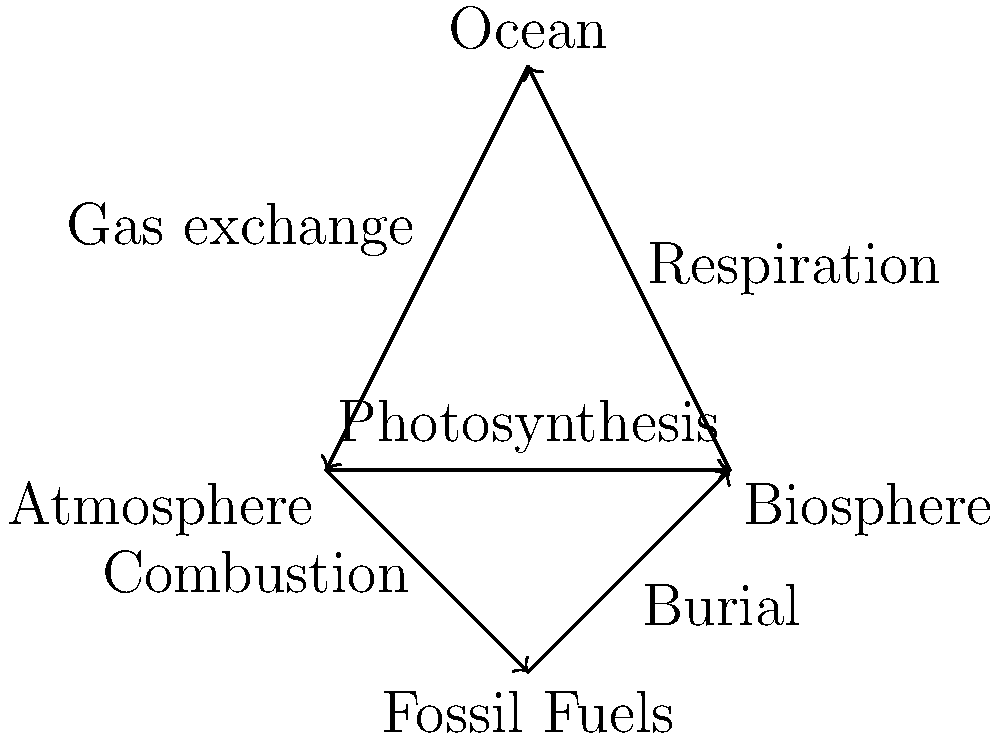In the carbon cycle diagram, which process counteracts the flow of carbon from the atmosphere to the biosphere through photosynthesis? To answer this question, let's analyze the carbon cycle diagram step-by-step:

1. First, we identify the flow of carbon from the atmosphere to the biosphere through photosynthesis. This is represented by the arrow pointing from "Atmosphere" to "Biosphere" labeled "Photosynthesis".

2. Next, we need to find a process that moves carbon in the opposite direction, from the biosphere back to the atmosphere or to another reservoir.

3. Looking at the diagram, we can see an arrow pointing from "Biosphere" to "Ocean" labeled "Respiration".

4. Respiration is the process by which organisms break down organic compounds to release energy, producing CO₂ as a byproduct. This CO₂ is then released back into the atmosphere or dissolved in water bodies.

5. While the arrow in the diagram shows respiration moving carbon from the biosphere to the ocean, it's important to note that respiration also releases CO₂ directly into the atmosphere. The simplification in the diagram doesn't show this direct pathway.

6. Therefore, respiration acts as a counterbalance to photosynthesis by releasing CO₂ that was previously fixed by photosynthesis back into the atmosphere.

Given your expertise in integrating classical and modern techniques, you would recognize that while this diagram provides a simplified view of the carbon cycle, it effectively illustrates the key processes and their interconnections.
Answer: Respiration 